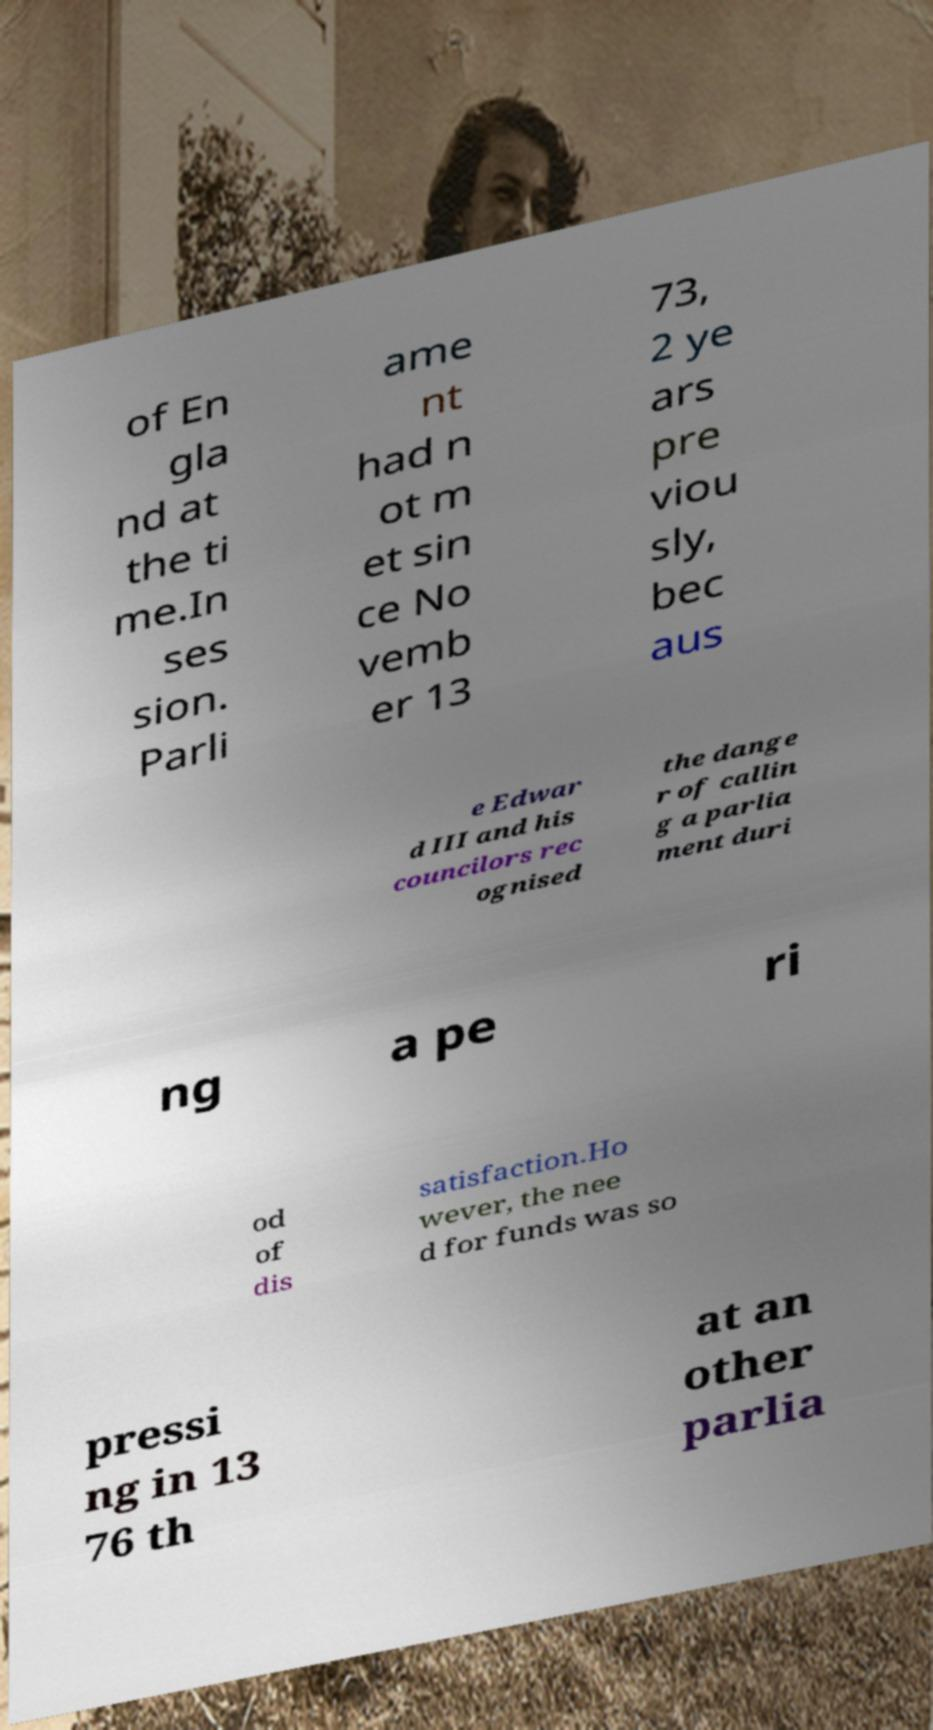For documentation purposes, I need the text within this image transcribed. Could you provide that? of En gla nd at the ti me.In ses sion. Parli ame nt had n ot m et sin ce No vemb er 13 73, 2 ye ars pre viou sly, bec aus e Edwar d III and his councilors rec ognised the dange r of callin g a parlia ment duri ng a pe ri od of dis satisfaction.Ho wever, the nee d for funds was so pressi ng in 13 76 th at an other parlia 